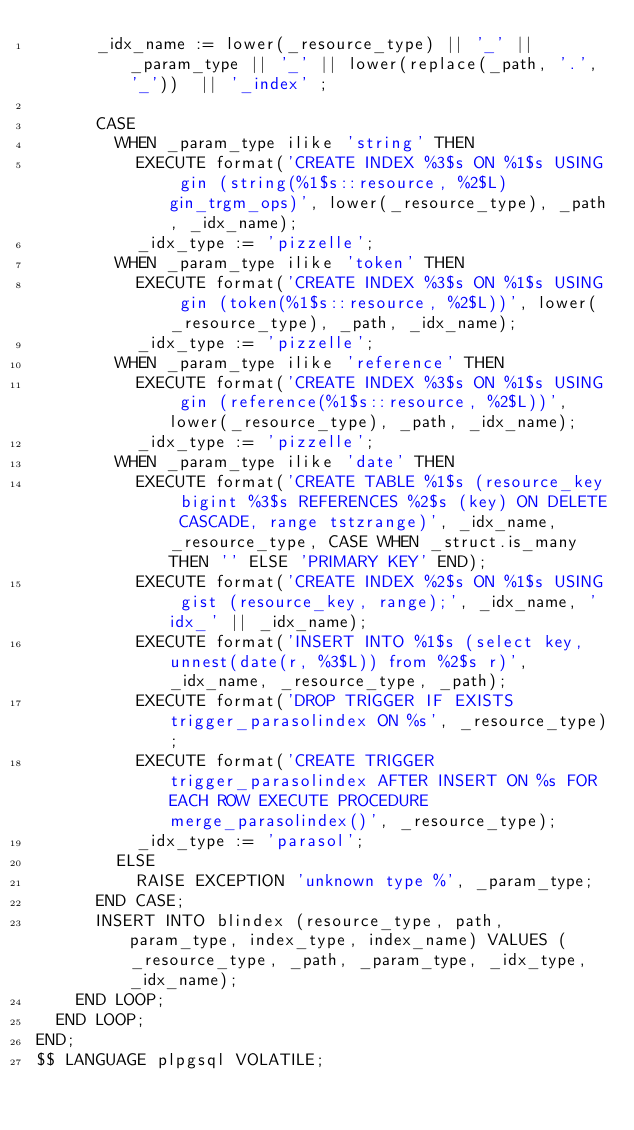<code> <loc_0><loc_0><loc_500><loc_500><_SQL_>      _idx_name := lower(_resource_type) || '_' || _param_type || '_' || lower(replace(_path, '.', '_'))  || '_index' ;

      CASE
        WHEN _param_type ilike 'string' THEN
          EXECUTE format('CREATE INDEX %3$s ON %1$s USING gin (string(%1$s::resource, %2$L) gin_trgm_ops)', lower(_resource_type), _path, _idx_name);
          _idx_type := 'pizzelle';
        WHEN _param_type ilike 'token' THEN
          EXECUTE format('CREATE INDEX %3$s ON %1$s USING gin (token(%1$s::resource, %2$L))', lower(_resource_type), _path, _idx_name);
          _idx_type := 'pizzelle';
        WHEN _param_type ilike 'reference' THEN
          EXECUTE format('CREATE INDEX %3$s ON %1$s USING gin (reference(%1$s::resource, %2$L))', lower(_resource_type), _path, _idx_name);
          _idx_type := 'pizzelle';
        WHEN _param_type ilike 'date' THEN
          EXECUTE format('CREATE TABLE %1$s (resource_key bigint %3$s REFERENCES %2$s (key) ON DELETE CASCADE, range tstzrange)', _idx_name, _resource_type, CASE WHEN _struct.is_many THEN '' ELSE 'PRIMARY KEY' END);
          EXECUTE format('CREATE INDEX %2$s ON %1$s USING gist (resource_key, range);', _idx_name, 'idx_' || _idx_name);
          EXECUTE format('INSERT INTO %1$s (select key, unnest(date(r, %3$L)) from %2$s r)', _idx_name, _resource_type, _path);
          EXECUTE format('DROP TRIGGER IF EXISTS trigger_parasolindex ON %s', _resource_type);
          EXECUTE format('CREATE TRIGGER trigger_parasolindex AFTER INSERT ON %s FOR EACH ROW EXECUTE PROCEDURE merge_parasolindex()', _resource_type);
          _idx_type := 'parasol';
        ELSE
          RAISE EXCEPTION 'unknown type %', _param_type;
      END CASE;
      INSERT INTO blindex (resource_type, path, param_type, index_type, index_name) VALUES (_resource_type, _path, _param_type, _idx_type, _idx_name);
    END LOOP;
  END LOOP;
END;
$$ LANGUAGE plpgsql VOLATILE;</code> 